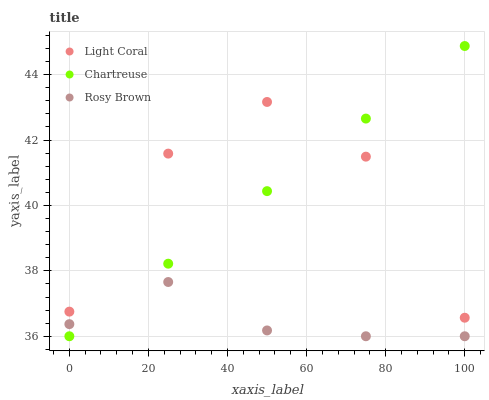Does Rosy Brown have the minimum area under the curve?
Answer yes or no. Yes. Does Light Coral have the maximum area under the curve?
Answer yes or no. Yes. Does Chartreuse have the minimum area under the curve?
Answer yes or no. No. Does Chartreuse have the maximum area under the curve?
Answer yes or no. No. Is Chartreuse the smoothest?
Answer yes or no. Yes. Is Light Coral the roughest?
Answer yes or no. Yes. Is Rosy Brown the smoothest?
Answer yes or no. No. Is Rosy Brown the roughest?
Answer yes or no. No. Does Chartreuse have the lowest value?
Answer yes or no. Yes. Does Chartreuse have the highest value?
Answer yes or no. Yes. Does Rosy Brown have the highest value?
Answer yes or no. No. Is Rosy Brown less than Light Coral?
Answer yes or no. Yes. Is Light Coral greater than Rosy Brown?
Answer yes or no. Yes. Does Light Coral intersect Chartreuse?
Answer yes or no. Yes. Is Light Coral less than Chartreuse?
Answer yes or no. No. Is Light Coral greater than Chartreuse?
Answer yes or no. No. Does Rosy Brown intersect Light Coral?
Answer yes or no. No. 